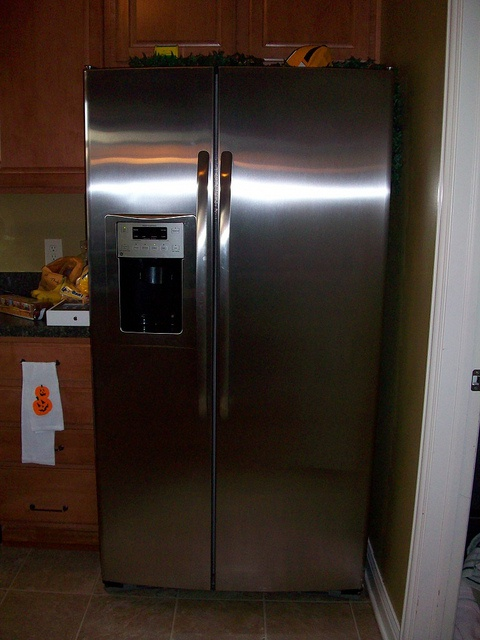Describe the objects in this image and their specific colors. I can see a refrigerator in black, gray, white, and darkgray tones in this image. 